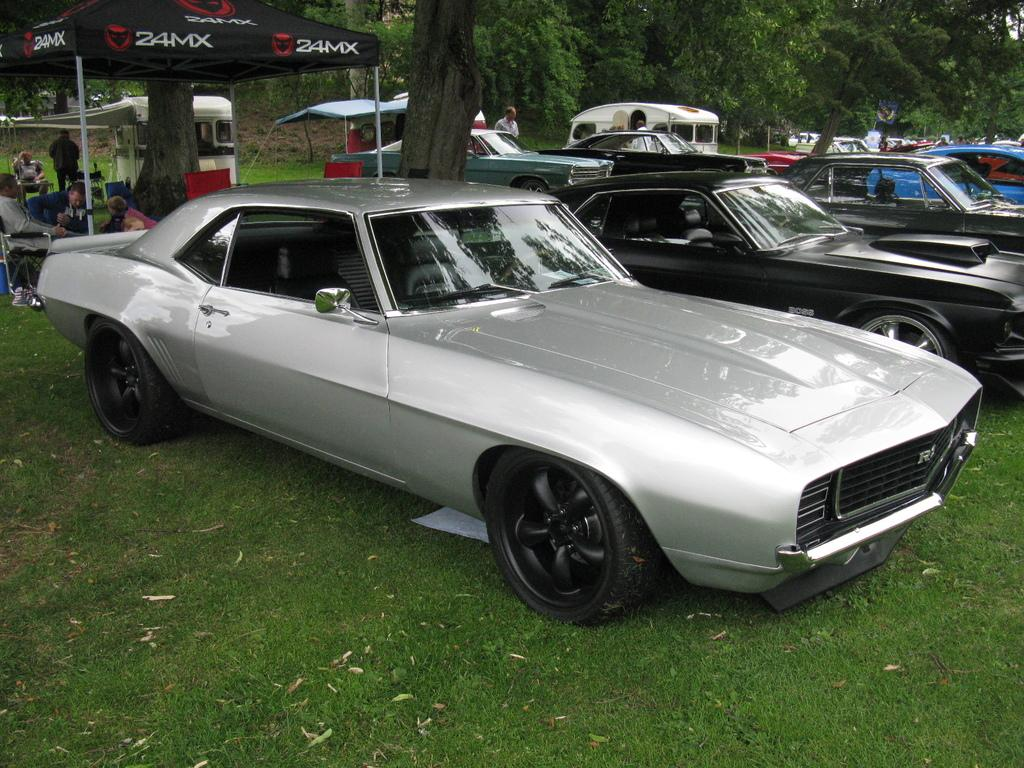What color is the car on the left side of the image? There is no car on the left side of the image; the silver-colored car is on the right side. What color is the car on the right side of the image? The car on the right side of the image is black-colored. What is located on the left side of the image? There is a tent on the left side of the image. Where is the tent situated in relation to the trees? The tent is under trees. How many rings are visible on the fingers of the girls in the image? There are no girls present in the image; it features a silver-colored car, a black-colored car, a tent, and trees. 